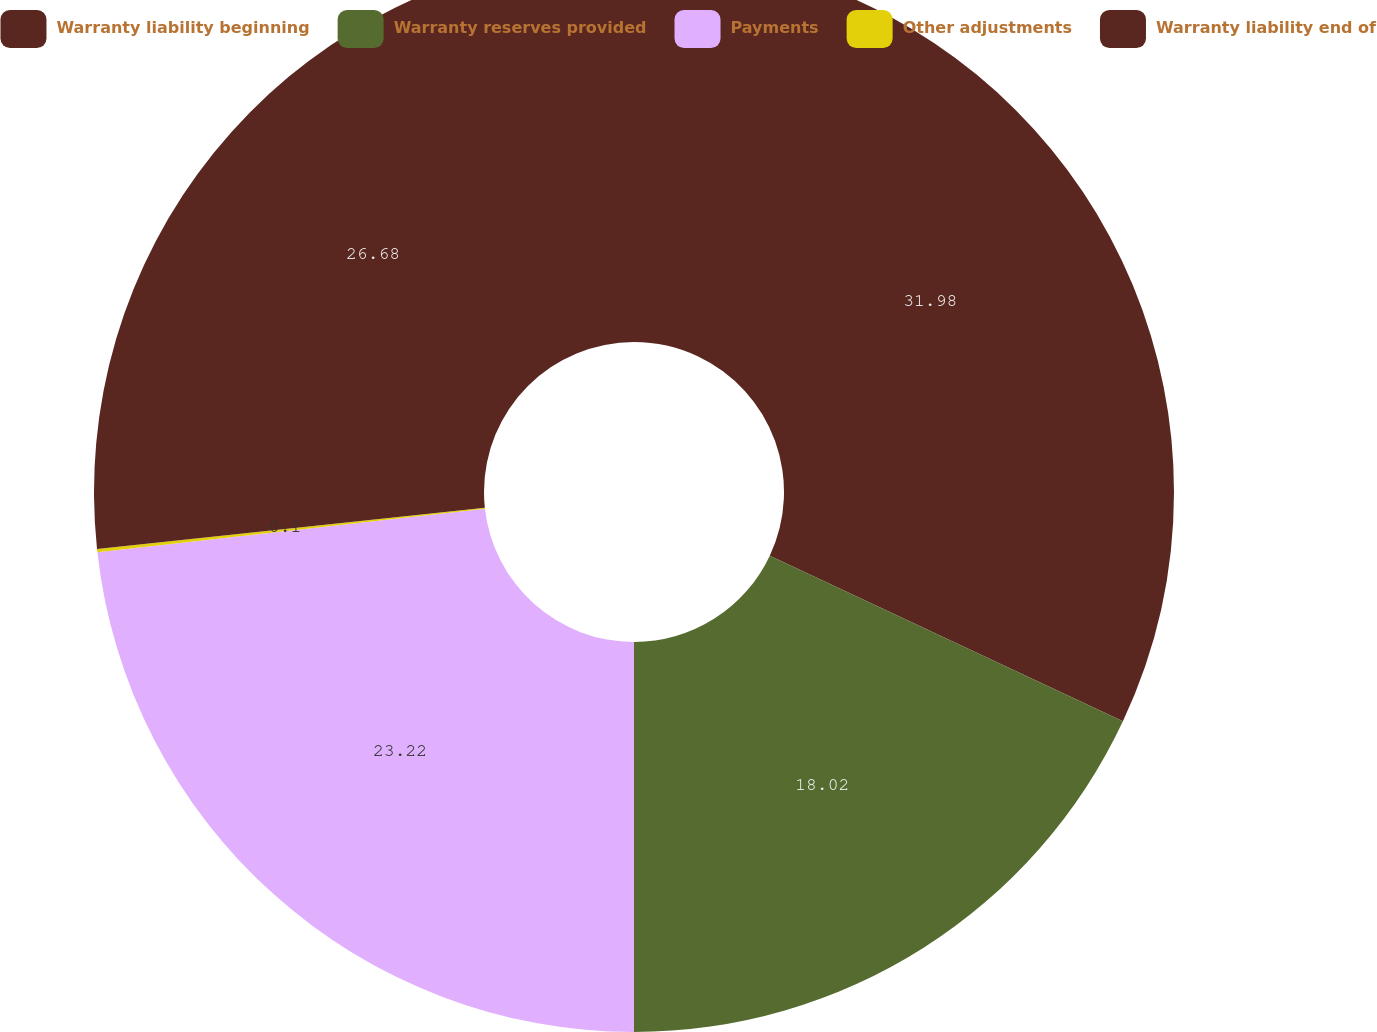Convert chart. <chart><loc_0><loc_0><loc_500><loc_500><pie_chart><fcel>Warranty liability beginning<fcel>Warranty reserves provided<fcel>Payments<fcel>Other adjustments<fcel>Warranty liability end of<nl><fcel>31.98%<fcel>18.02%<fcel>23.22%<fcel>0.1%<fcel>26.68%<nl></chart> 